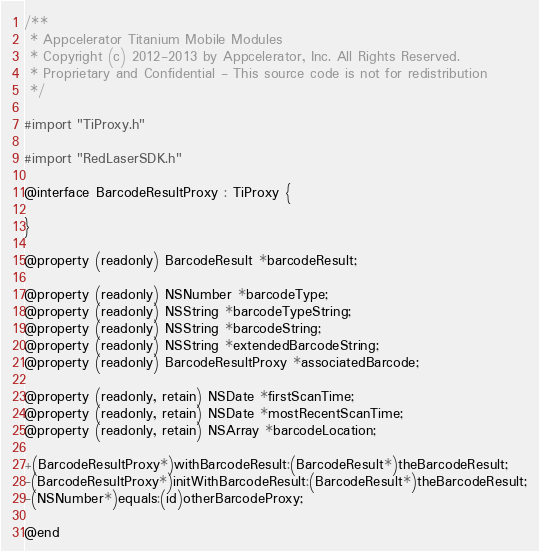<code> <loc_0><loc_0><loc_500><loc_500><_C_>/**
 * Appcelerator Titanium Mobile Modules
 * Copyright (c) 2012-2013 by Appcelerator, Inc. All Rights Reserved.
 * Proprietary and Confidential - This source code is not for redistribution
 */

#import "TiProxy.h"

#import "RedLaserSDK.h"

@interface BarcodeResultProxy : TiProxy {
    
}

@property (readonly) BarcodeResult *barcodeResult;

@property (readonly) NSNumber *barcodeType;
@property (readonly) NSString *barcodeTypeString;
@property (readonly) NSString *barcodeString;
@property (readonly) NSString *extendedBarcodeString;
@property (readonly) BarcodeResultProxy *associatedBarcode;

@property (readonly, retain) NSDate *firstScanTime;
@property (readonly, retain) NSDate *mostRecentScanTime;
@property (readonly, retain) NSArray *barcodeLocation;

+(BarcodeResultProxy*)withBarcodeResult:(BarcodeResult*)theBarcodeResult;
-(BarcodeResultProxy*)initWithBarcodeResult:(BarcodeResult*)theBarcodeResult;
-(NSNumber*)equals:(id)otherBarcodeProxy;

@end
</code> 